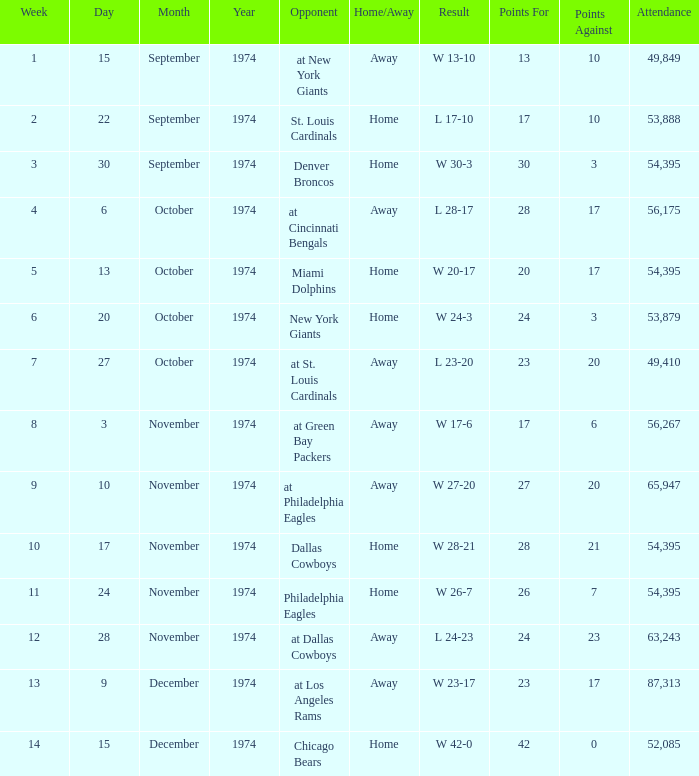What was the result of the game where 63,243 people attended after week 9? W 23-17. 